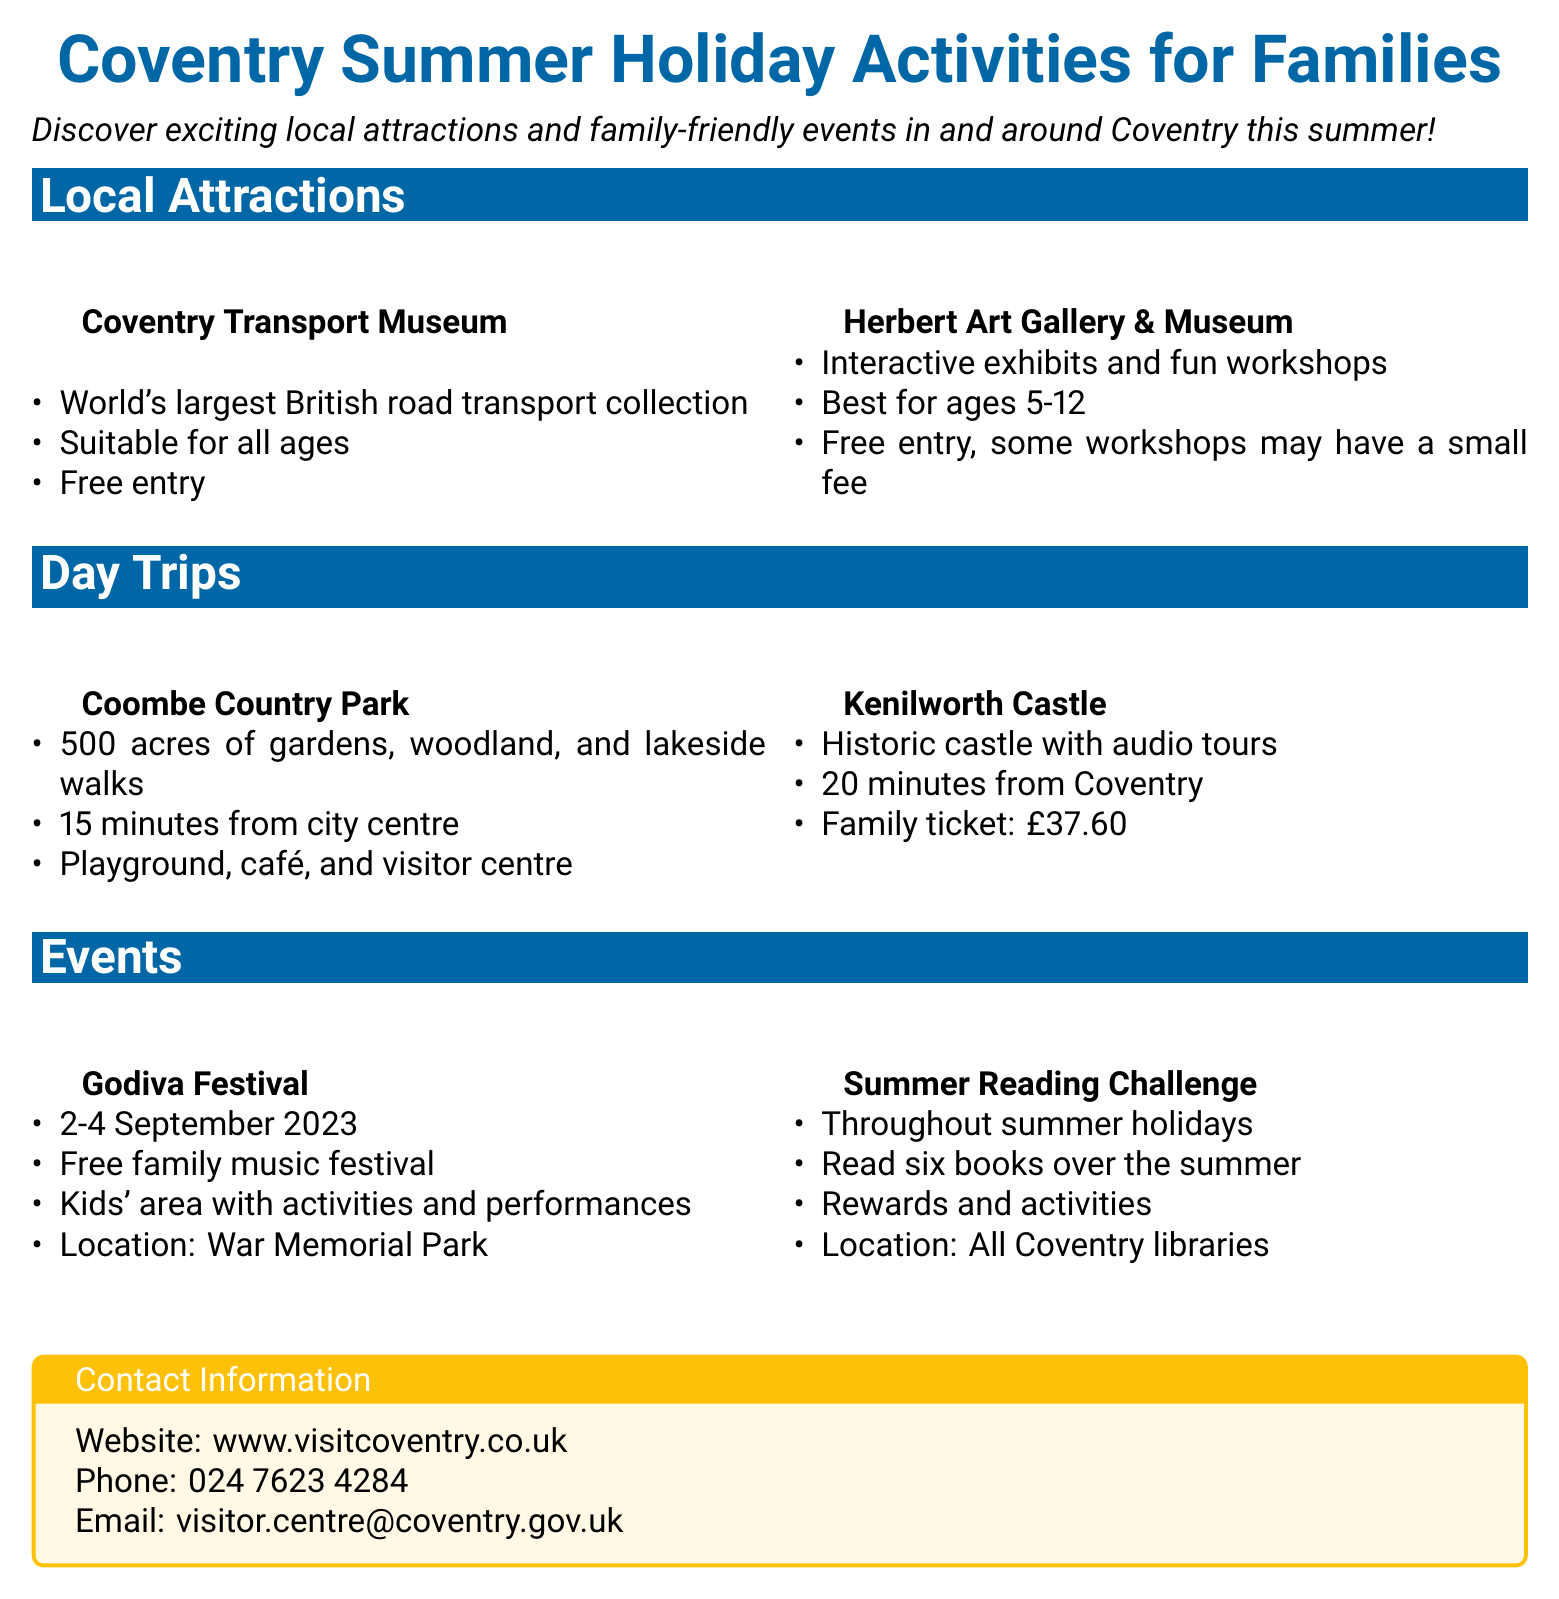What is the opening date of the Godiva Festival? The Godiva Festival takes place from 2-4 September 2023.
Answer: 2-4 September 2023 How much is a family ticket to Kenilworth Castle? A family ticket to Kenilworth Castle is priced at £37.60.
Answer: £37.60 What activity is associated with the Summer Reading Challenge? The Summer Reading Challenge requires participants to read six books over the summer.
Answer: Read six books Is entry to the Herbert Art Gallery & Museum free? The document states that entry to the Herbert Art Gallery & Museum is free, although some workshops may have a small fee.
Answer: Free entry What is the primary feature of Coventry Transport Museum? The primary feature of Coventry Transport Museum is the world's largest British road transport collection.
Answer: World's largest British road transport collection How far is Coombe Country Park from the city centre? Coombe Country Park is located 15 minutes from the city centre.
Answer: 15 minutes 